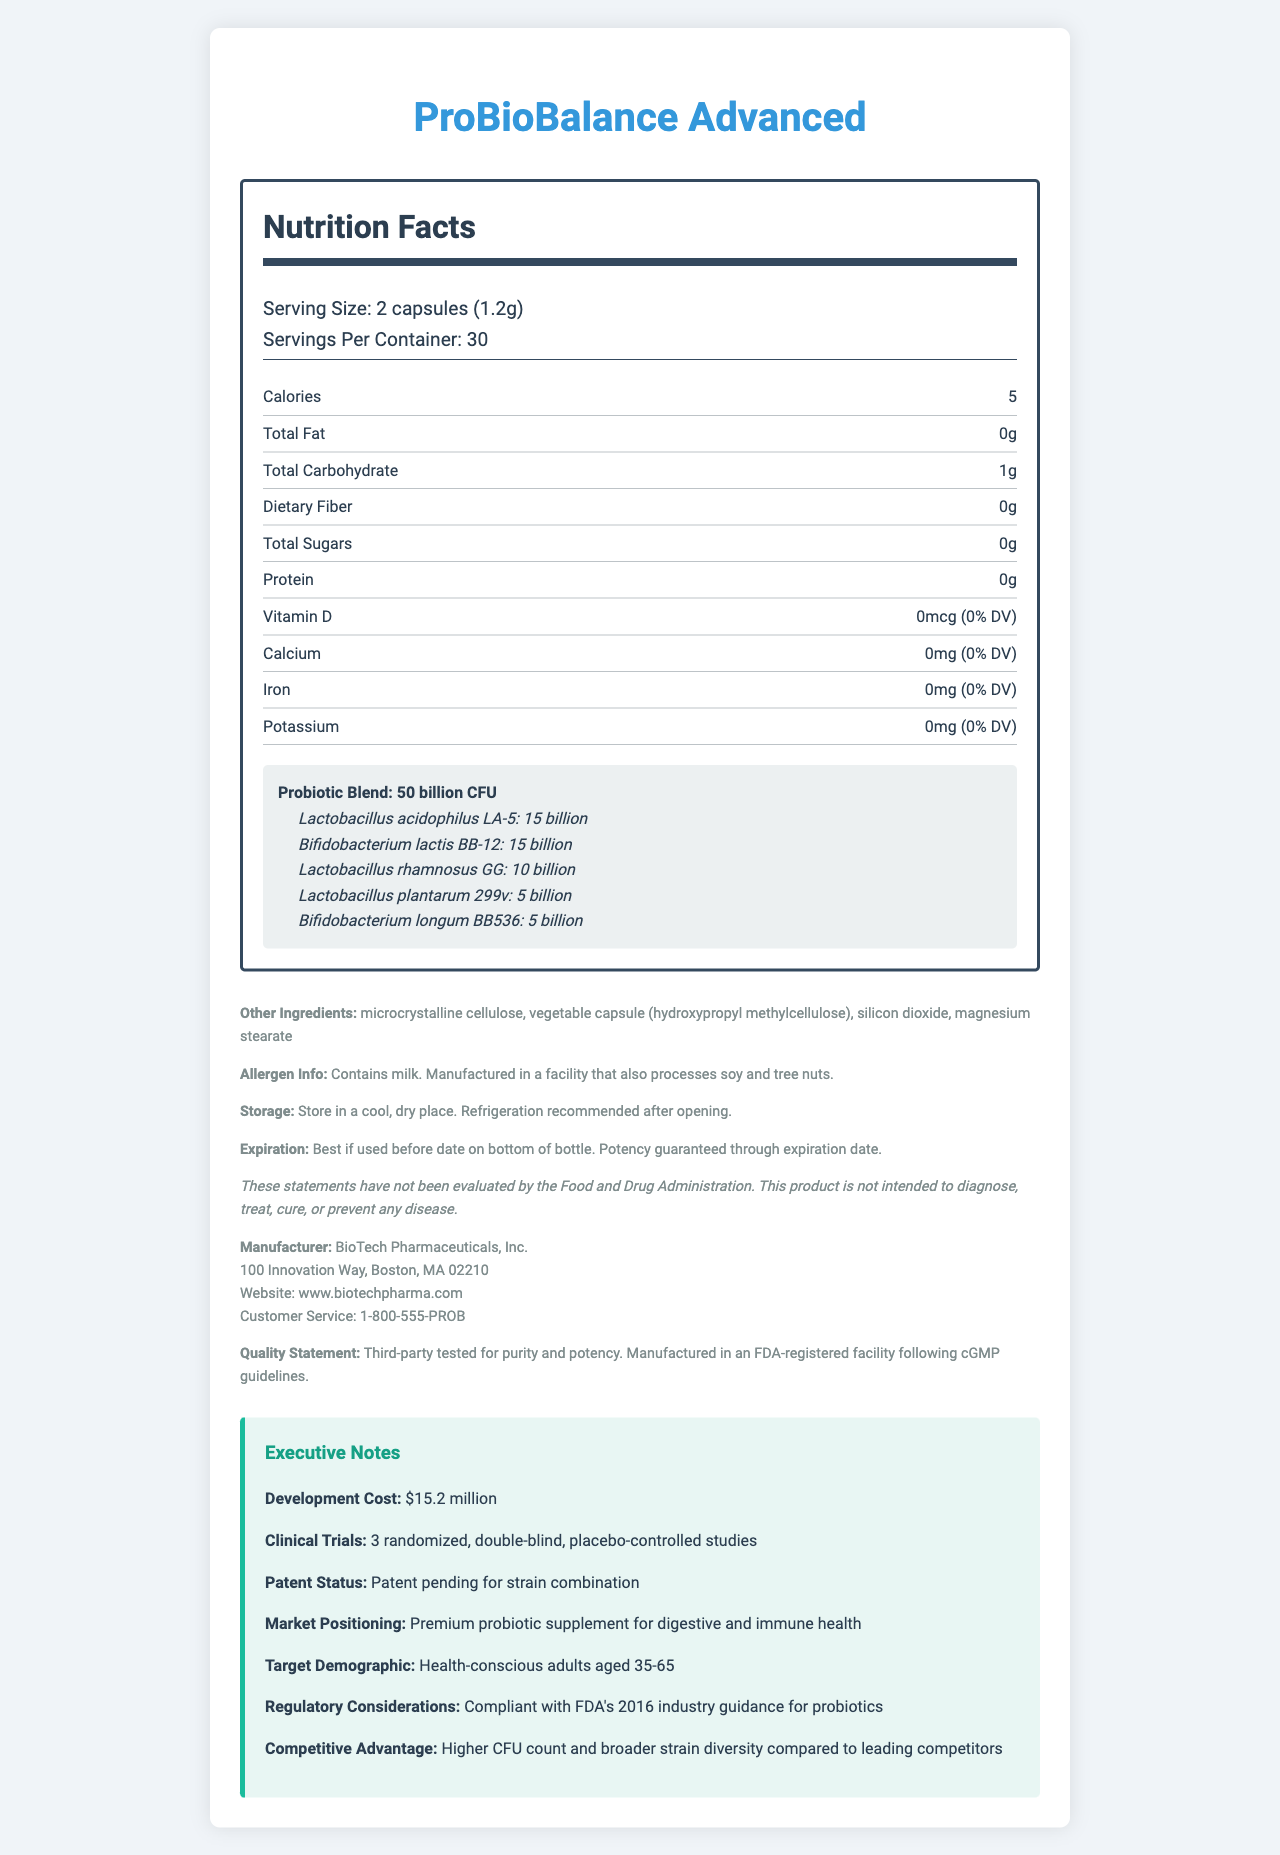what is the serving size? The serving size is clearly stated as "2 capsules (1.2g)" right at the top of the nutrition facts section.
Answer: 2 capsules (1.2g) how many calories are in one serving? The nutrition facts list "Calories" as 5 per serving.
Answer: 5 calories which strain has the highest CFU count? The probiotic strain Lactobacillus acidophilus LA-5 has the highest CFU count of 15 billion.
Answer: Lactobacillus acidophilus LA-5 what ingredients are listed under other ingredients? Under the section "Other Ingredients," these four components are listed.
Answer: Microcrystalline cellulose, vegetable capsule (hydroxypropyl methylcellulose), silicon dioxide, magnesium stearate how many clinical trials were conducted for this product? The executive notes mention that there were 3 randomized, double-blind, placebo-controlled studies.
Answer: 3 randomized, double-blind, placebo-controlled studies what is the total number of CFU in the probiotic blend? The probiotic blend is noted to contain a total of 50 billion CFU.
Answer: 50 billion CFU what is the serving size of ProBioBalance Advanced? A. 1 capsule (0.6g) B. 2 capsules (1.2g) C. 3 capsules (1.8g) The serving size is listed as "2 capsules (1.2g)."
Answer: B which probiotic strain is not included in this supplement? A. Bifidobacterium lactis BB-12 B. Lactobacillus rhamnosus GG C. Saccharomyces boulardii Saccharomyces boulardii is not listed among the probiotic strains in the supplement.
Answer: C does the product contain any allergens? The allergen information states that it contains milk and is manufactured in a facility that processes soy and tree nuts.
Answer: Yes summarize the key benefits and features of ProBioBalance Advanced. The document summarizes the product's purpose, key ingredients, and competitive advantages, as well as details on manufacturing standards and allergen information.
Answer: ProBioBalance Advanced is a premium probiotic supplement designed for digestive and immune health. It contains a blend of 50 billion CFU from five different probiotic strains: Lactobacillus acidophilus LA-5, Bifidobacterium lactis BB-12, Lactobacillus rhamnosus GG, Lactobacillus plantarum 299v, and Bifidobacterium longum BB536. The product is developed by BioTech Pharmaceuticals and has undergone rigorous clinical trials. The supplement is noted for its higher CFU count and broader strain diversity compared to leading competitors. what is the development cost of ProBioBalance Advanced? The executive notes specify that the development cost of ProBioBalance Advanced is $15.2 million.
Answer: $15.2 million where is BioTech Pharmaceuticals Inc., the manufacturer of this probiotic, located? The manufacturer's address is listed as 100 Innovation Way, Boston, MA 02210.
Answer: 100 Innovation Way, Boston, MA 02210 what is the recommended storage condition for this product after opening? A. Keep in a warm place B. Store in a cool, dry place. Refrigeration recommended after opening. C. Store in a humid environment. The storage instructions specifically state to "store in a cool, dry place. Refrigeration recommended after opening."
Answer: B can we determine the market positioning for ProBioBalance Advanced from the document? The executive notes mention that the market positioning is as a "Premium probiotic supplement for digestive and immune health."
Answer: Yes what is the aim of labeling foods with the CFU count for probiotic supplements? The document does not detail the specific aim of labeling foods with CFU counts for probiotic supplements.
Answer: Not enough information 